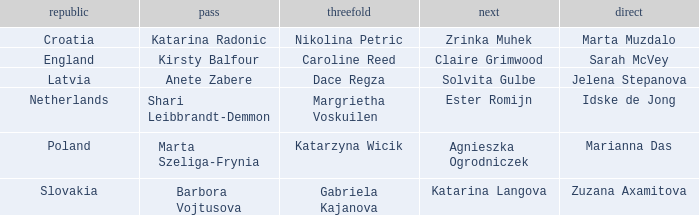Could you help me parse every detail presented in this table? {'header': ['republic', 'pass', 'threefold', 'next', 'direct'], 'rows': [['Croatia', 'Katarina Radonic', 'Nikolina Petric', 'Zrinka Muhek', 'Marta Muzdalo'], ['England', 'Kirsty Balfour', 'Caroline Reed', 'Claire Grimwood', 'Sarah McVey'], ['Latvia', 'Anete Zabere', 'Dace Regza', 'Solvita Gulbe', 'Jelena Stepanova'], ['Netherlands', 'Shari Leibbrandt-Demmon', 'Margrietha Voskuilen', 'Ester Romijn', 'Idske de Jong'], ['Poland', 'Marta Szeliga-Frynia', 'Katarzyna Wicik', 'Agnieszka Ogrodniczek', 'Marianna Das'], ['Slovakia', 'Barbora Vojtusova', 'Gabriela Kajanova', 'Katarina Langova', 'Zuzana Axamitova']]} Who is the Second with Nikolina Petric as Third? Zrinka Muhek. 